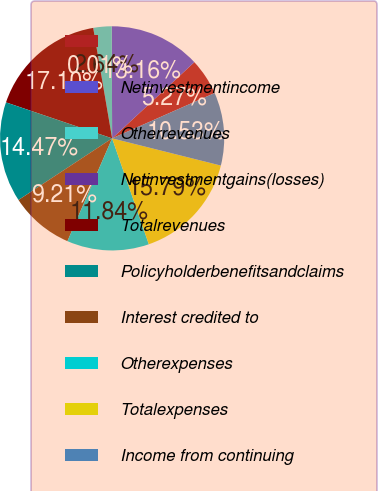Convert chart. <chart><loc_0><loc_0><loc_500><loc_500><pie_chart><ecel><fcel>Netinvestmentincome<fcel>Otherrevenues<fcel>Netinvestmentgains(losses)<fcel>Totalrevenues<fcel>Policyholderbenefitsandclaims<fcel>Interest credited to<fcel>Otherexpenses<fcel>Totalexpenses<fcel>Income from continuing<nl><fcel>5.27%<fcel>13.16%<fcel>2.64%<fcel>0.01%<fcel>17.1%<fcel>14.47%<fcel>9.21%<fcel>11.84%<fcel>15.79%<fcel>10.53%<nl></chart> 